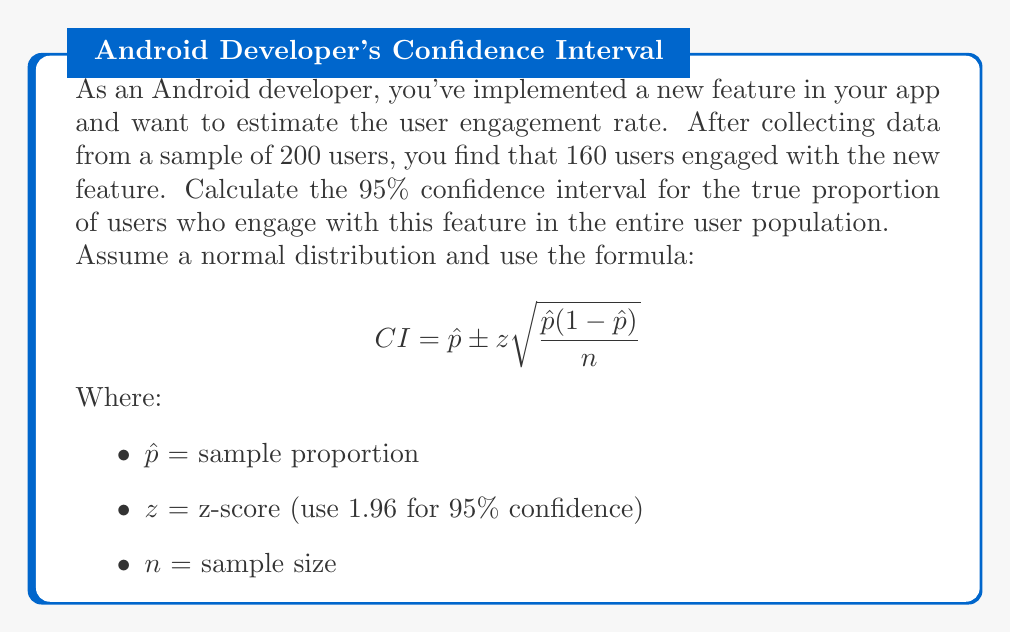Help me with this question. Let's follow these steps to calculate the confidence interval:

1. Calculate the sample proportion $\hat{p}$:
   $\hat{p} = \frac{\text{number of successes}}{\text{sample size}} = \frac{160}{200} = 0.8$

2. Determine the z-score for 95% confidence interval:
   $z = 1.96$

3. Calculate the standard error:
   $SE = \sqrt{\frac{\hat{p}(1-\hat{p})}{n}} = \sqrt{\frac{0.8(1-0.8)}{200}} = \sqrt{\frac{0.16}{200}} = 0.0283$

4. Calculate the margin of error:
   $ME = z \times SE = 1.96 \times 0.0283 = 0.0555$

5. Calculate the lower and upper bounds of the confidence interval:
   $CI = \hat{p} \pm ME$
   Lower bound: $0.8 - 0.0555 = 0.7445$
   Upper bound: $0.8 + 0.0555 = 0.8555$

Therefore, we can be 95% confident that the true proportion of users who engage with the new feature falls between 0.7445 and 0.8555, or approximately 74.45% to 85.55%.
Answer: (0.7445, 0.8555) 